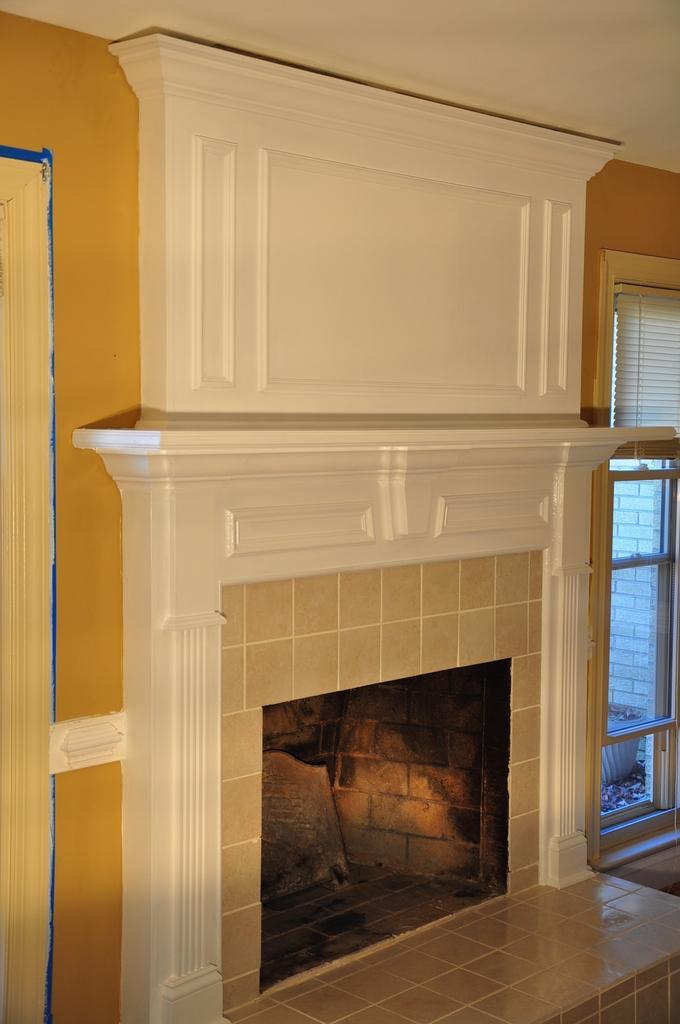In one or two sentences, can you explain what this image depicts? The image is taken in the room. In the center of the image we can see a fireplace. On the right there is a window and a curtain. We can see a wall. 